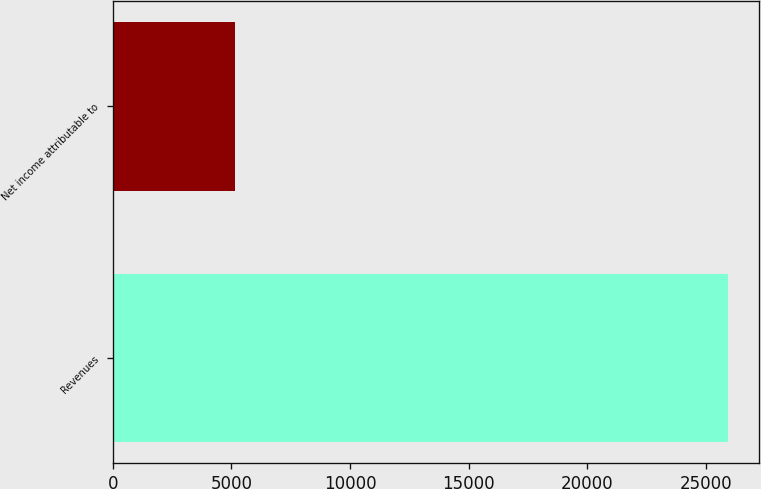<chart> <loc_0><loc_0><loc_500><loc_500><bar_chart><fcel>Revenues<fcel>Net income attributable to<nl><fcel>25939<fcel>5157<nl></chart> 